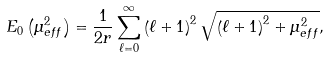Convert formula to latex. <formula><loc_0><loc_0><loc_500><loc_500>E _ { 0 } \left ( \mu _ { e f f } ^ { 2 } \right ) = \frac { 1 } { 2 r } \sum _ { \ell = 0 } ^ { \infty } \left ( \ell + 1 \right ) ^ { 2 } \sqrt { \left ( \ell + 1 \right ) ^ { 2 } + \mu _ { e f f } ^ { 2 } } ,</formula> 